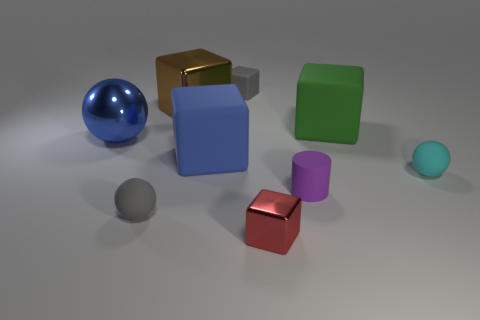Are these objects intended to represent any specific theme or concept? The arrangement and variety of shapes and colors could symbolize diversity or individuality. Each object is unique in color and material, which might imply a message about the uniqueness of individuals in a group. 